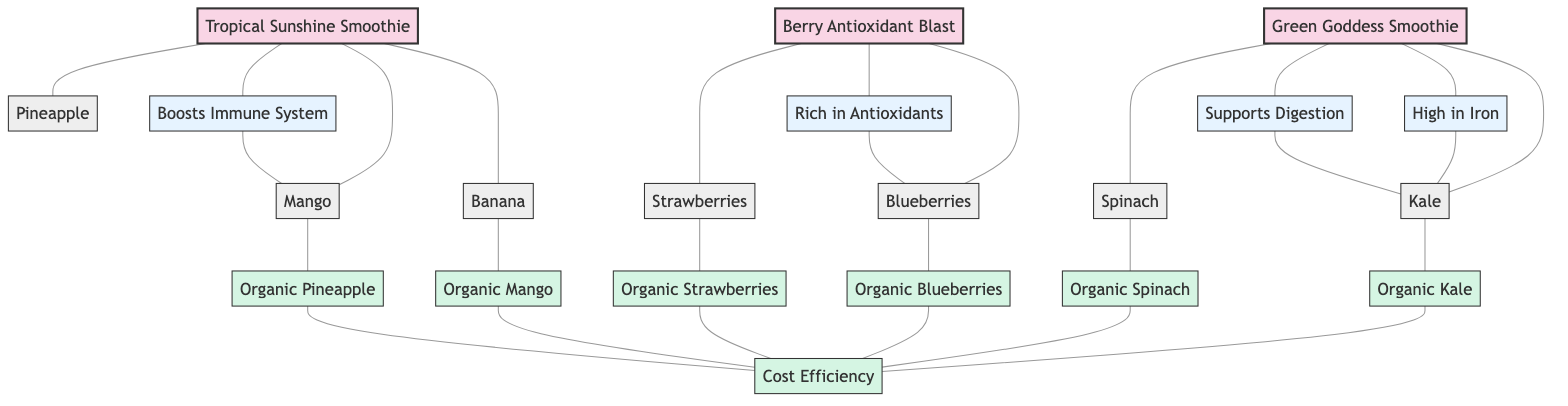What are the ingredients in the Green Goddess Smoothie? The Green Goddess Smoothie is connected to Kale and Spinach as its ingredients. By locating the node for Green Goddess Smoothie, I can follow the edges leading to the respective ingredient nodes.
Answer: Kale, Spinach How many smoothies are represented in the diagram? The diagram includes three smoothie nodes: Green Goddess Smoothie, Berry Antioxidant Blast, and Tropical Sunshine Smoothie. Counting these nodes provides the answer.
Answer: 3 Which smoothie contains ingredients that are high in antioxidants? Berry Antioxidant Blast is the smoothie connected to the ingredient nodes Blueberries and Strawberries, which are commonly known for their high antioxidant content. Therefore, I can identify the smoothie based on these ingredient connections.
Answer: Berry Antioxidant Blast What are the health benefits of the Tropical Sunshine Smoothie? The Tropical Sunshine Smoothie connects to the benefit node Boosts Immune System. By examining the edges connected to this smoothie node, I can find the corresponding health benefit.
Answer: Boosts Immune System Which ingredient is associated with high iron content? The ingredient Kale is linked to the health benefit node High in Iron. By tracing from the ingredient node through its edges to the benefit node provides me with the answer.
Answer: Kale How many edges are connected to organic produce? Each organic ingredient (Organic Kale, Organic Spinach, Organic Blueberries, Organic Strawberries, Organic Mango, Organic Pineapple) connects to the cost efficiency node, totaling six connections. Additionally, since there are six organic ingredients all pointing to one cost efficiency node, that counts for six edges.
Answer: 6 What is the common benefit associated with Kale? Both High in Iron and Supports Digestion are the benefits connected to Kale. By tracing from the Kale ingredient node to its benefit connections, I find the two benefits associated with it.
Answer: High in Iron, Supports Digestion What is the relationship between organic produce and cost efficiency? The organic ingredients are all connected to a single node labeled Cost Efficiency. This shows that all organic produce contributes to or is associated with cost efficiency in smoothies.
Answer: Cost Efficiency Which fruit is included in the Tropical Sunshine Smoothie? The Tropical Sunshine Smoothie is connected to the ingredient nodes Mango and Pineapple. By identifying the edges leading from this smoothie to its ingredients, I can see that these fruits are included.
Answer: Mango, Pineapple 